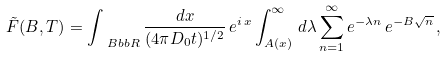<formula> <loc_0><loc_0><loc_500><loc_500>\tilde { F } ( B , T ) = \int _ { \ B b b { R } } \frac { d x } { ( 4 \pi D _ { 0 } t ) ^ { 1 / 2 } } \, { e } ^ { i \, x } \int _ { A ( x ) } ^ { \infty } \, d \lambda \sum _ { n = 1 } ^ { \infty } { e } ^ { - \lambda n } \, { e } ^ { - B \sqrt { n } } \, ,</formula> 